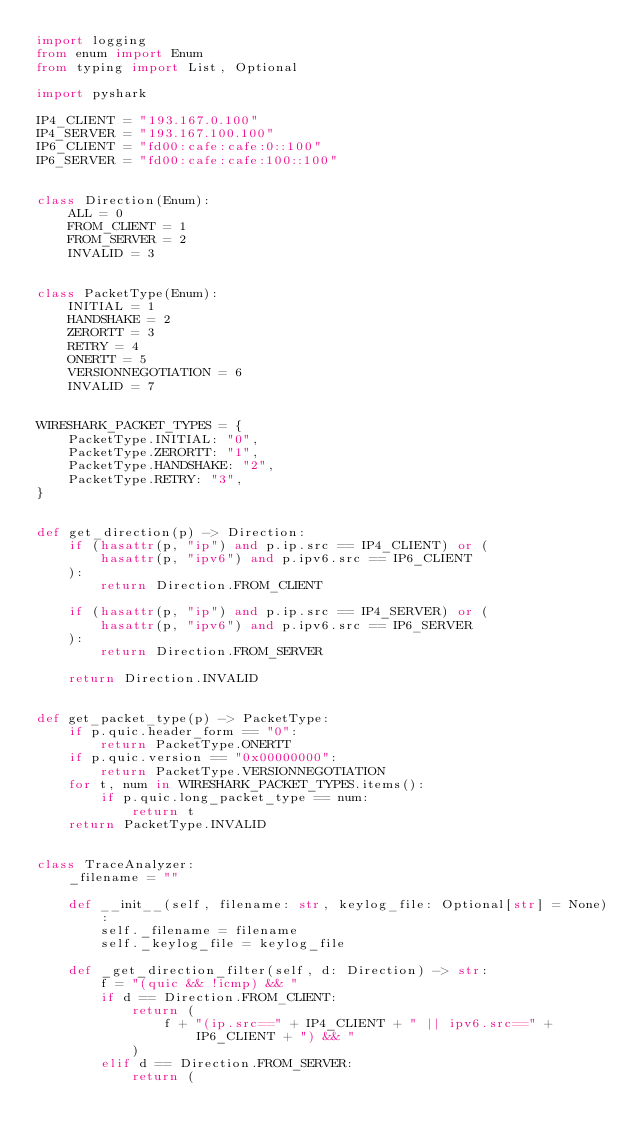<code> <loc_0><loc_0><loc_500><loc_500><_Python_>import logging
from enum import Enum
from typing import List, Optional

import pyshark

IP4_CLIENT = "193.167.0.100"
IP4_SERVER = "193.167.100.100"
IP6_CLIENT = "fd00:cafe:cafe:0::100"
IP6_SERVER = "fd00:cafe:cafe:100::100"


class Direction(Enum):
    ALL = 0
    FROM_CLIENT = 1
    FROM_SERVER = 2
    INVALID = 3


class PacketType(Enum):
    INITIAL = 1
    HANDSHAKE = 2
    ZERORTT = 3
    RETRY = 4
    ONERTT = 5
    VERSIONNEGOTIATION = 6
    INVALID = 7


WIRESHARK_PACKET_TYPES = {
    PacketType.INITIAL: "0",
    PacketType.ZERORTT: "1",
    PacketType.HANDSHAKE: "2",
    PacketType.RETRY: "3",
}


def get_direction(p) -> Direction:
    if (hasattr(p, "ip") and p.ip.src == IP4_CLIENT) or (
        hasattr(p, "ipv6") and p.ipv6.src == IP6_CLIENT
    ):
        return Direction.FROM_CLIENT

    if (hasattr(p, "ip") and p.ip.src == IP4_SERVER) or (
        hasattr(p, "ipv6") and p.ipv6.src == IP6_SERVER
    ):
        return Direction.FROM_SERVER

    return Direction.INVALID


def get_packet_type(p) -> PacketType:
    if p.quic.header_form == "0":
        return PacketType.ONERTT
    if p.quic.version == "0x00000000":
        return PacketType.VERSIONNEGOTIATION
    for t, num in WIRESHARK_PACKET_TYPES.items():
        if p.quic.long_packet_type == num:
            return t
    return PacketType.INVALID


class TraceAnalyzer:
    _filename = ""

    def __init__(self, filename: str, keylog_file: Optional[str] = None):
        self._filename = filename
        self._keylog_file = keylog_file

    def _get_direction_filter(self, d: Direction) -> str:
        f = "(quic && !icmp) && "
        if d == Direction.FROM_CLIENT:
            return (
                f + "(ip.src==" + IP4_CLIENT + " || ipv6.src==" + IP6_CLIENT + ") && "
            )
        elif d == Direction.FROM_SERVER:
            return (</code> 